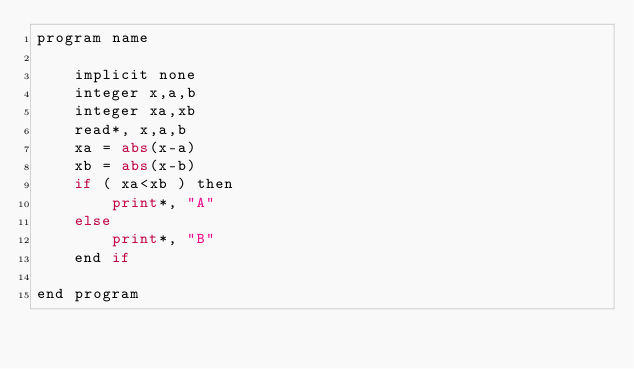<code> <loc_0><loc_0><loc_500><loc_500><_Python_>program name

    implicit none
    integer x,a,b
    integer xa,xb
    read*, x,a,b
    xa = abs(x-a)
    xb = abs(x-b)
    if ( xa<xb ) then
        print*, "A"
    else
        print*, "B"
    end if

end program</code> 